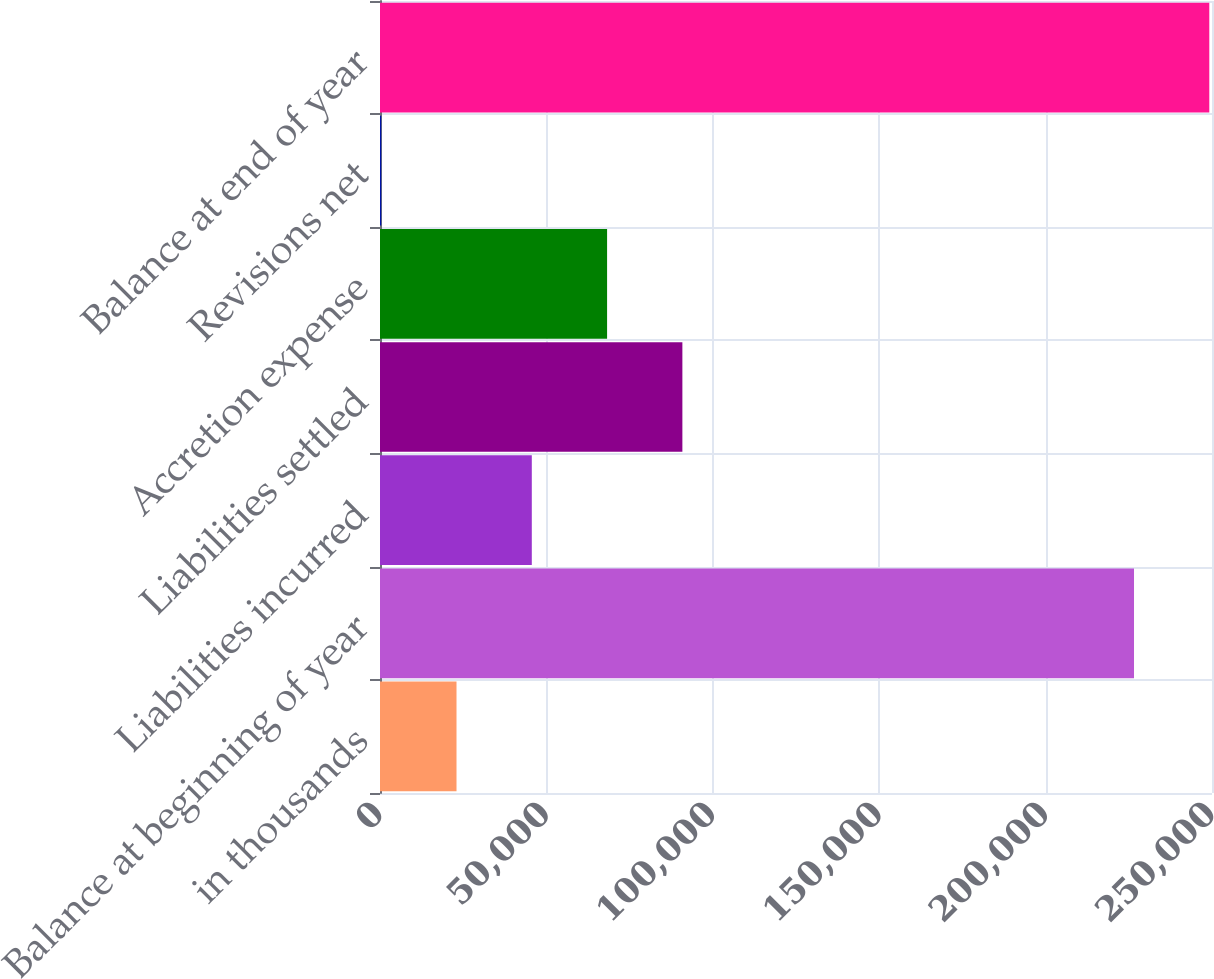Convert chart. <chart><loc_0><loc_0><loc_500><loc_500><bar_chart><fcel>in thousands<fcel>Balance at beginning of year<fcel>Liabilities incurred<fcel>Liabilities settled<fcel>Accretion expense<fcel>Revisions net<fcel>Balance at end of year<nl><fcel>22990.6<fcel>226565<fcel>45613.2<fcel>90858.4<fcel>68235.8<fcel>368<fcel>249188<nl></chart> 